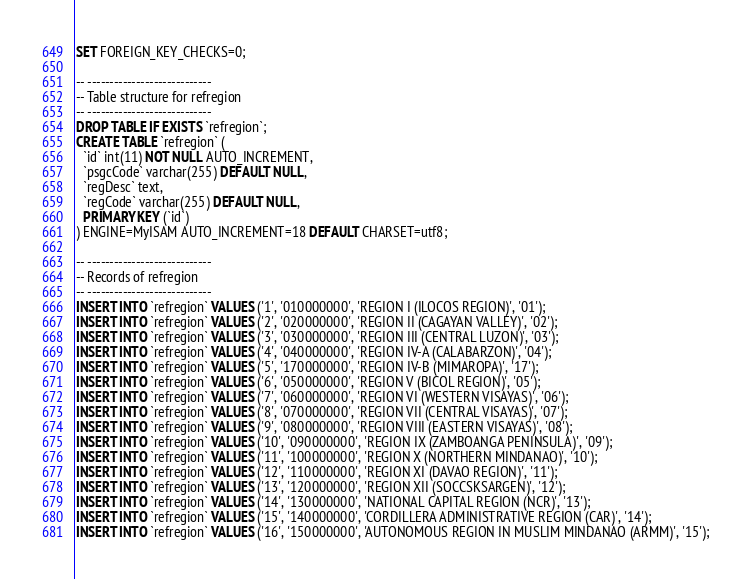<code> <loc_0><loc_0><loc_500><loc_500><_SQL_>SET FOREIGN_KEY_CHECKS=0;

-- ----------------------------
-- Table structure for refregion
-- ----------------------------
DROP TABLE IF EXISTS `refregion`;
CREATE TABLE `refregion` (
  `id` int(11) NOT NULL AUTO_INCREMENT,
  `psgcCode` varchar(255) DEFAULT NULL,
  `regDesc` text,
  `regCode` varchar(255) DEFAULT NULL,
  PRIMARY KEY (`id`)
) ENGINE=MyISAM AUTO_INCREMENT=18 DEFAULT CHARSET=utf8;

-- ----------------------------
-- Records of refregion
-- ----------------------------
INSERT INTO `refregion` VALUES ('1', '010000000', 'REGION I (ILOCOS REGION)', '01');
INSERT INTO `refregion` VALUES ('2', '020000000', 'REGION II (CAGAYAN VALLEY)', '02');
INSERT INTO `refregion` VALUES ('3', '030000000', 'REGION III (CENTRAL LUZON)', '03');
INSERT INTO `refregion` VALUES ('4', '040000000', 'REGION IV-A (CALABARZON)', '04');
INSERT INTO `refregion` VALUES ('5', '170000000', 'REGION IV-B (MIMAROPA)', '17');
INSERT INTO `refregion` VALUES ('6', '050000000', 'REGION V (BICOL REGION)', '05');
INSERT INTO `refregion` VALUES ('7', '060000000', 'REGION VI (WESTERN VISAYAS)', '06');
INSERT INTO `refregion` VALUES ('8', '070000000', 'REGION VII (CENTRAL VISAYAS)', '07');
INSERT INTO `refregion` VALUES ('9', '080000000', 'REGION VIII (EASTERN VISAYAS)', '08');
INSERT INTO `refregion` VALUES ('10', '090000000', 'REGION IX (ZAMBOANGA PENINSULA)', '09');
INSERT INTO `refregion` VALUES ('11', '100000000', 'REGION X (NORTHERN MINDANAO)', '10');
INSERT INTO `refregion` VALUES ('12', '110000000', 'REGION XI (DAVAO REGION)', '11');
INSERT INTO `refregion` VALUES ('13', '120000000', 'REGION XII (SOCCSKSARGEN)', '12');
INSERT INTO `refregion` VALUES ('14', '130000000', 'NATIONAL CAPITAL REGION (NCR)', '13');
INSERT INTO `refregion` VALUES ('15', '140000000', 'CORDILLERA ADMINISTRATIVE REGION (CAR)', '14');
INSERT INTO `refregion` VALUES ('16', '150000000', 'AUTONOMOUS REGION IN MUSLIM MINDANAO (ARMM)', '15');</code> 